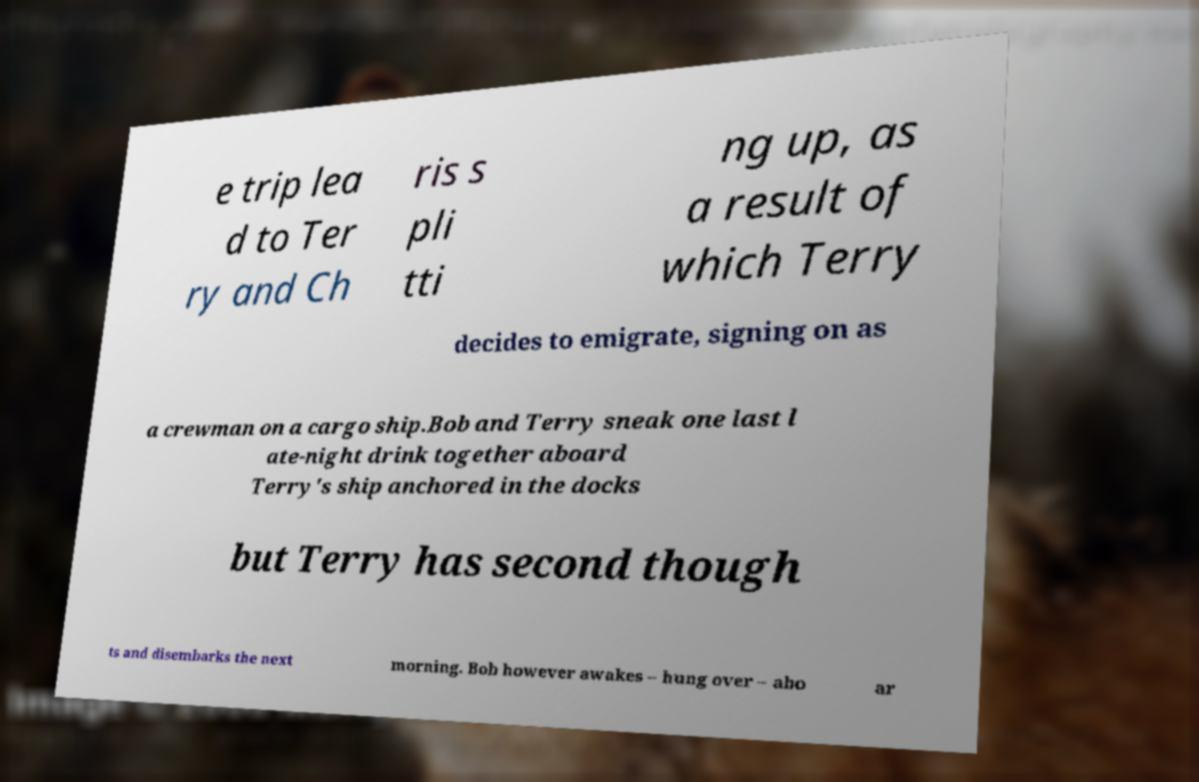Can you accurately transcribe the text from the provided image for me? e trip lea d to Ter ry and Ch ris s pli tti ng up, as a result of which Terry decides to emigrate, signing on as a crewman on a cargo ship.Bob and Terry sneak one last l ate-night drink together aboard Terry's ship anchored in the docks but Terry has second though ts and disembarks the next morning. Bob however awakes – hung over – abo ar 